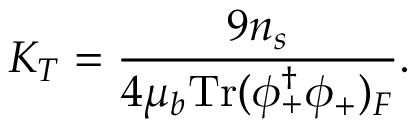<formula> <loc_0><loc_0><loc_500><loc_500>K _ { T } = \frac { 9 n _ { s } } { 4 \mu _ { b } T r ( \phi _ { + } ^ { \dagger } \phi _ { + } ) _ { F } } .</formula> 